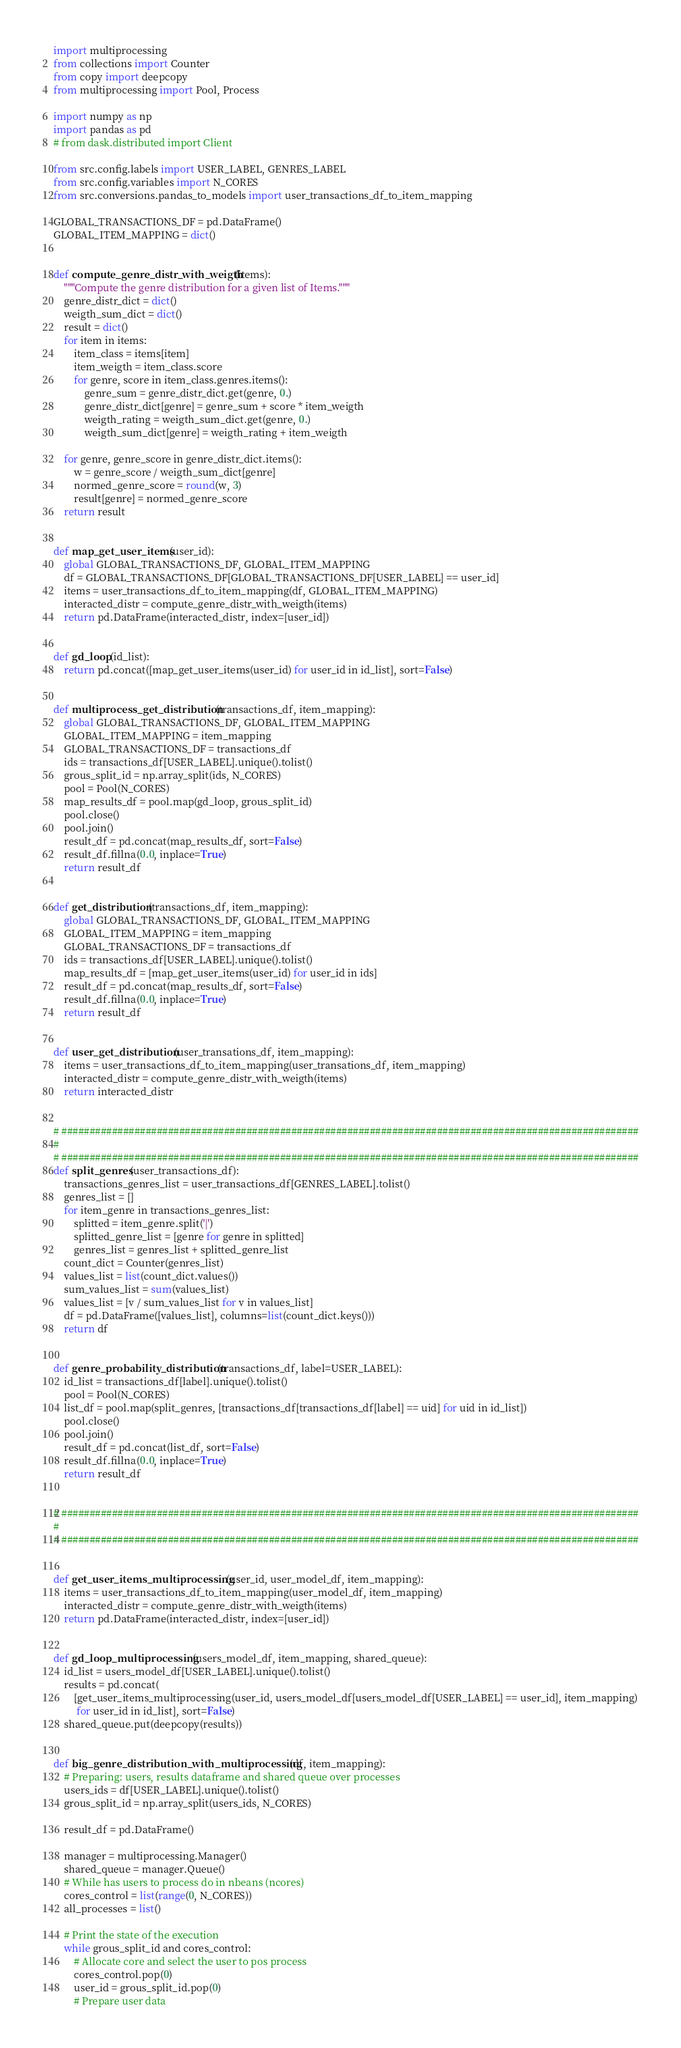<code> <loc_0><loc_0><loc_500><loc_500><_Python_>import multiprocessing
from collections import Counter
from copy import deepcopy
from multiprocessing import Pool, Process

import numpy as np
import pandas as pd
# from dask.distributed import Client

from src.config.labels import USER_LABEL, GENRES_LABEL
from src.config.variables import N_CORES
from src.conversions.pandas_to_models import user_transactions_df_to_item_mapping

GLOBAL_TRANSACTIONS_DF = pd.DataFrame()
GLOBAL_ITEM_MAPPING = dict()


def compute_genre_distr_with_weigth(items):
    """Compute the genre distribution for a given list of Items."""
    genre_distr_dict = dict()
    weigth_sum_dict = dict()
    result = dict()
    for item in items:
        item_class = items[item]
        item_weigth = item_class.score
        for genre, score in item_class.genres.items():
            genre_sum = genre_distr_dict.get(genre, 0.)
            genre_distr_dict[genre] = genre_sum + score * item_weigth
            weigth_rating = weigth_sum_dict.get(genre, 0.)
            weigth_sum_dict[genre] = weigth_rating + item_weigth

    for genre, genre_score in genre_distr_dict.items():
        w = genre_score / weigth_sum_dict[genre]
        normed_genre_score = round(w, 3)
        result[genre] = normed_genre_score
    return result


def map_get_user_items(user_id):
    global GLOBAL_TRANSACTIONS_DF, GLOBAL_ITEM_MAPPING
    df = GLOBAL_TRANSACTIONS_DF[GLOBAL_TRANSACTIONS_DF[USER_LABEL] == user_id]
    items = user_transactions_df_to_item_mapping(df, GLOBAL_ITEM_MAPPING)
    interacted_distr = compute_genre_distr_with_weigth(items)
    return pd.DataFrame(interacted_distr, index=[user_id])


def gd_loop(id_list):
    return pd.concat([map_get_user_items(user_id) for user_id in id_list], sort=False)


def multiprocess_get_distribution(transactions_df, item_mapping):
    global GLOBAL_TRANSACTIONS_DF, GLOBAL_ITEM_MAPPING
    GLOBAL_ITEM_MAPPING = item_mapping
    GLOBAL_TRANSACTIONS_DF = transactions_df
    ids = transactions_df[USER_LABEL].unique().tolist()
    grous_split_id = np.array_split(ids, N_CORES)
    pool = Pool(N_CORES)
    map_results_df = pool.map(gd_loop, grous_split_id)
    pool.close()
    pool.join()
    result_df = pd.concat(map_results_df, sort=False)
    result_df.fillna(0.0, inplace=True)
    return result_df


def get_distribution(transactions_df, item_mapping):
    global GLOBAL_TRANSACTIONS_DF, GLOBAL_ITEM_MAPPING
    GLOBAL_ITEM_MAPPING = item_mapping
    GLOBAL_TRANSACTIONS_DF = transactions_df
    ids = transactions_df[USER_LABEL].unique().tolist()
    map_results_df = [map_get_user_items(user_id) for user_id in ids]
    result_df = pd.concat(map_results_df, sort=False)
    result_df.fillna(0.0, inplace=True)
    return result_df


def user_get_distribution(user_transations_df, item_mapping):
    items = user_transactions_df_to_item_mapping(user_transations_df, item_mapping)
    interacted_distr = compute_genre_distr_with_weigth(items)
    return interacted_distr


# #######################################################################################################
#
# #######################################################################################################
def split_genres(user_transactions_df):
    transactions_genres_list = user_transactions_df[GENRES_LABEL].tolist()
    genres_list = []
    for item_genre in transactions_genres_list:
        splitted = item_genre.split('|')
        splitted_genre_list = [genre for genre in splitted]
        genres_list = genres_list + splitted_genre_list
    count_dict = Counter(genres_list)
    values_list = list(count_dict.values())
    sum_values_list = sum(values_list)
    values_list = [v / sum_values_list for v in values_list]
    df = pd.DataFrame([values_list], columns=list(count_dict.keys()))
    return df


def genre_probability_distribution(transactions_df, label=USER_LABEL):
    id_list = transactions_df[label].unique().tolist()
    pool = Pool(N_CORES)
    list_df = pool.map(split_genres, [transactions_df[transactions_df[label] == uid] for uid in id_list])
    pool.close()
    pool.join()
    result_df = pd.concat(list_df, sort=False)
    result_df.fillna(0.0, inplace=True)
    return result_df


# #######################################################################################################
#
# #######################################################################################################


def get_user_items_multiprocessing(user_id, user_model_df, item_mapping):
    items = user_transactions_df_to_item_mapping(user_model_df, item_mapping)
    interacted_distr = compute_genre_distr_with_weigth(items)
    return pd.DataFrame(interacted_distr, index=[user_id])


def gd_loop_multiprocessing(users_model_df, item_mapping, shared_queue):
    id_list = users_model_df[USER_LABEL].unique().tolist()
    results = pd.concat(
        [get_user_items_multiprocessing(user_id, users_model_df[users_model_df[USER_LABEL] == user_id], item_mapping)
         for user_id in id_list], sort=False)
    shared_queue.put(deepcopy(results))


def big_genre_distribution_with_multiprocessing(df, item_mapping):
    # Preparing: users, results dataframe and shared queue over processes
    users_ids = df[USER_LABEL].unique().tolist()
    grous_split_id = np.array_split(users_ids, N_CORES)

    result_df = pd.DataFrame()

    manager = multiprocessing.Manager()
    shared_queue = manager.Queue()
    # While has users to process do in nbeans (ncores)
    cores_control = list(range(0, N_CORES))
    all_processes = list()

    # Print the state of the execution
    while grous_split_id and cores_control:
        # Allocate core and select the user to pos process
        cores_control.pop(0)
        user_id = grous_split_id.pop(0)
        # Prepare user data</code> 